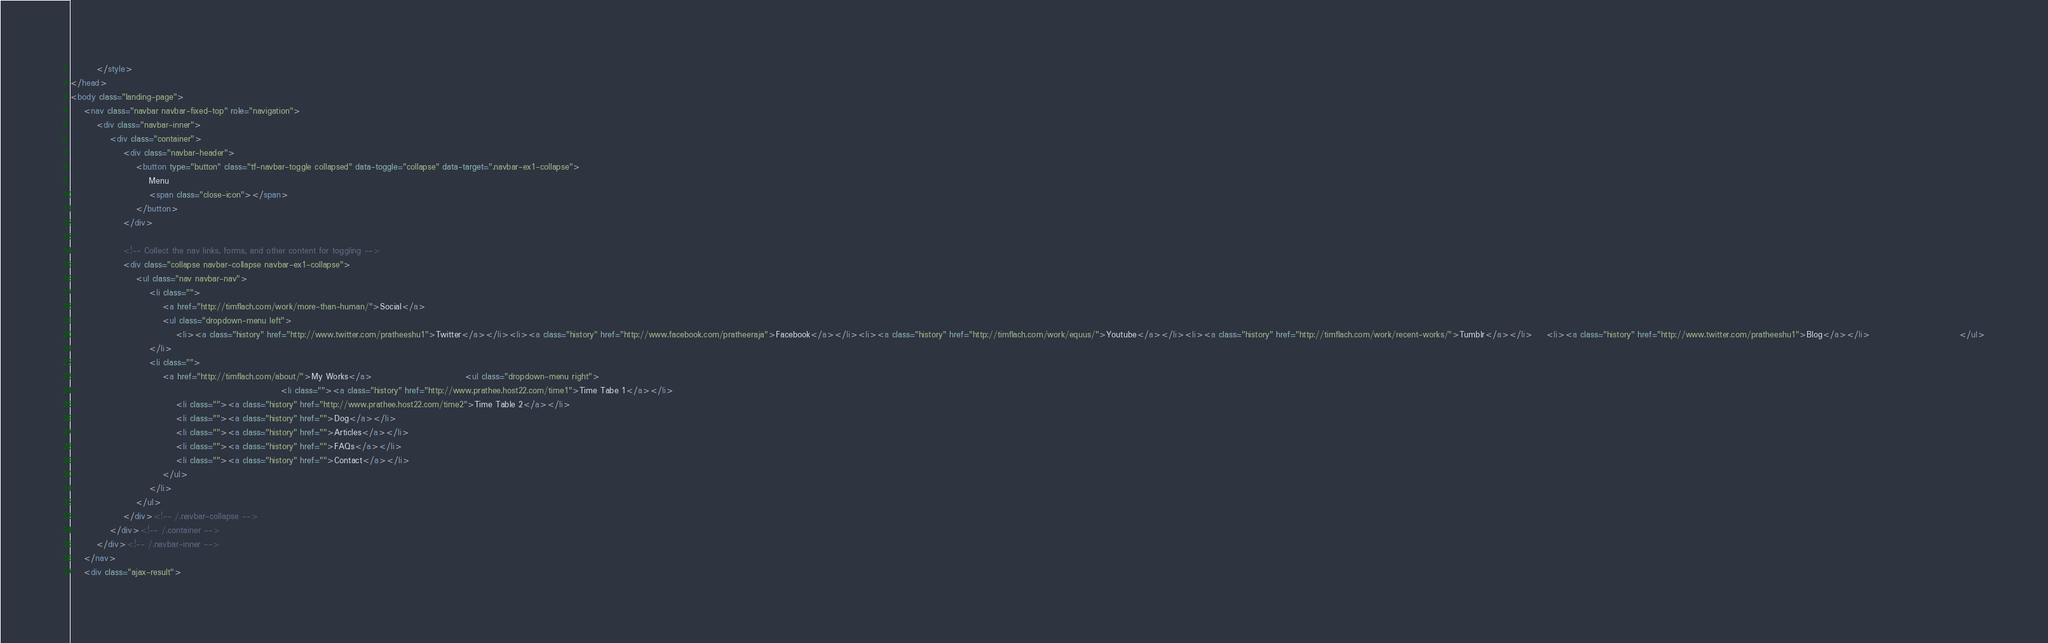<code> <loc_0><loc_0><loc_500><loc_500><_HTML_>		</style>
</head>
<body class="landing-page">
    <nav class="navbar navbar-fixed-top" role="navigation">
        <div class="navbar-inner">
            <div class="container">
                <div class="navbar-header">
                    <button type="button" class="tf-navbar-toggle collapsed" data-toggle="collapse" data-target=".navbar-ex1-collapse">
                        Menu
                        <span class="close-icon"></span>
                    </button>
                </div>

                <!-- Collect the nav links, forms, and other content for toggling -->
                <div class="collapse navbar-collapse navbar-ex1-collapse">
                    <ul class="nav navbar-nav">
                        <li class="">
                            <a href="http://timflach.com/work/more-than-human/">Social</a>
                            <ul class="dropdown-menu left">
                                <li><a class="history" href="http://www.twitter.com/pratheeshu1">Twitter</a></li><li><a class="history" href="http://www.facebook.com/pratheeraja">Facebook</a></li><li><a class="history" href="http://timflach.com/work/equus/">Youtube</a></li><li><a class="history" href="http://timflach.com/work/recent-works/">Tumblr</a></li>    <li><a class="history" href="http://www.twitter.com/pratheeshu1">Blog</a></li>                           </ul>
                        </li>
                        <li class="">
                            <a href="http://timflach.com/about/">My Works</a>                            <ul class="dropdown-menu right">
                                                                <li class=""><a class="history" href="http://www.prathee.host22.com/time1">Time Tabe 1</a></li>
                                <li class=""><a class="history" href="http://www.prathee.host22.com/time2">Time Table 2</a></li>
                                <li class=""><a class="history" href="">Dog</a></li>
                                <li class=""><a class="history" href="">Articles</a></li>
                                <li class=""><a class="history" href="">FAQs</a></li>
                                <li class=""><a class="history" href="">Contact</a></li>
                            </ul>
                        </li>
                    </ul>
                </div><!-- /.navbar-collapse -->
            </div><!-- /.container -->
        </div><!-- /.navbar-inner -->
    </nav>
    <div class="ajax-result"></code> 